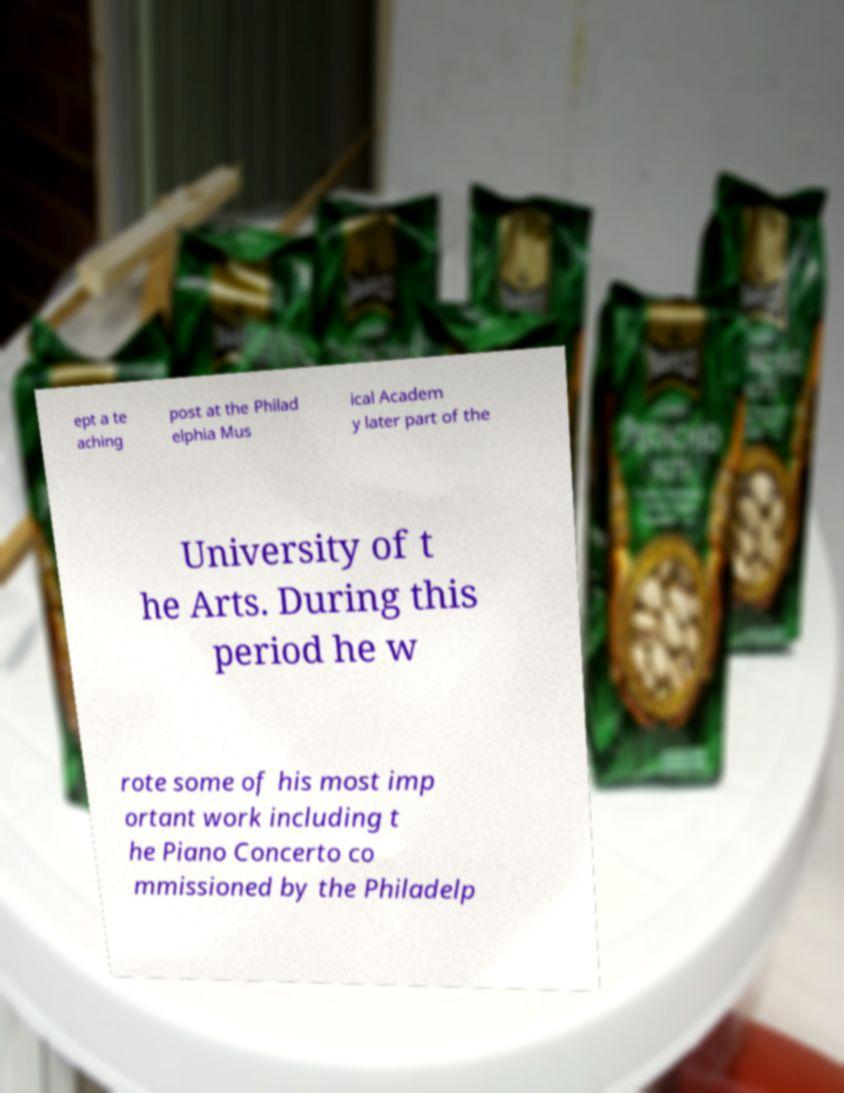For documentation purposes, I need the text within this image transcribed. Could you provide that? ept a te aching post at the Philad elphia Mus ical Academ y later part of the University of t he Arts. During this period he w rote some of his most imp ortant work including t he Piano Concerto co mmissioned by the Philadelp 